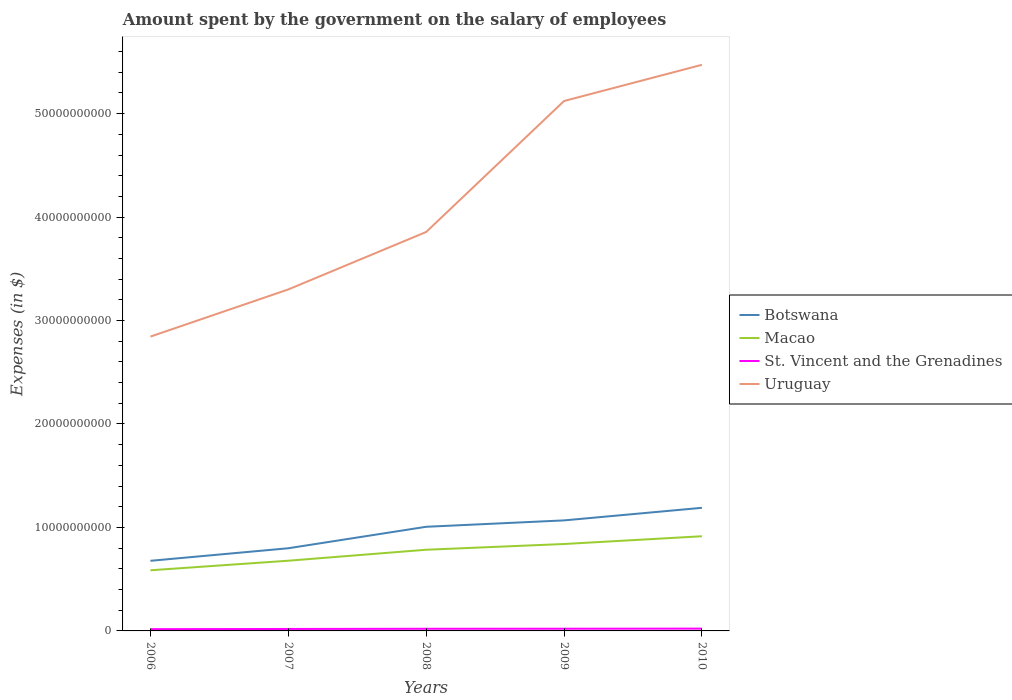How many different coloured lines are there?
Give a very brief answer. 4. Does the line corresponding to Botswana intersect with the line corresponding to Uruguay?
Make the answer very short. No. Across all years, what is the maximum amount spent on the salary of employees by the government in Botswana?
Give a very brief answer. 6.78e+09. What is the total amount spent on the salary of employees by the government in Macao in the graph?
Your answer should be compact. -9.25e+08. What is the difference between the highest and the second highest amount spent on the salary of employees by the government in St. Vincent and the Grenadines?
Your answer should be compact. 5.05e+07. What is the difference between the highest and the lowest amount spent on the salary of employees by the government in Botswana?
Provide a succinct answer. 3. How many lines are there?
Provide a short and direct response. 4. How many years are there in the graph?
Keep it short and to the point. 5. What is the difference between two consecutive major ticks on the Y-axis?
Your response must be concise. 1.00e+1. Are the values on the major ticks of Y-axis written in scientific E-notation?
Offer a terse response. No. Where does the legend appear in the graph?
Your response must be concise. Center right. What is the title of the graph?
Make the answer very short. Amount spent by the government on the salary of employees. What is the label or title of the X-axis?
Offer a very short reply. Years. What is the label or title of the Y-axis?
Ensure brevity in your answer.  Expenses (in $). What is the Expenses (in $) of Botswana in 2006?
Provide a short and direct response. 6.78e+09. What is the Expenses (in $) in Macao in 2006?
Ensure brevity in your answer.  5.86e+09. What is the Expenses (in $) of St. Vincent and the Grenadines in 2006?
Provide a succinct answer. 1.71e+08. What is the Expenses (in $) in Uruguay in 2006?
Make the answer very short. 2.84e+1. What is the Expenses (in $) of Botswana in 2007?
Your answer should be compact. 7.99e+09. What is the Expenses (in $) of Macao in 2007?
Give a very brief answer. 6.79e+09. What is the Expenses (in $) in St. Vincent and the Grenadines in 2007?
Offer a terse response. 1.89e+08. What is the Expenses (in $) in Uruguay in 2007?
Your response must be concise. 3.30e+1. What is the Expenses (in $) in Botswana in 2008?
Ensure brevity in your answer.  1.01e+1. What is the Expenses (in $) of Macao in 2008?
Provide a succinct answer. 7.85e+09. What is the Expenses (in $) of St. Vincent and the Grenadines in 2008?
Make the answer very short. 2.07e+08. What is the Expenses (in $) of Uruguay in 2008?
Give a very brief answer. 3.86e+1. What is the Expenses (in $) of Botswana in 2009?
Give a very brief answer. 1.07e+1. What is the Expenses (in $) of Macao in 2009?
Your response must be concise. 8.40e+09. What is the Expenses (in $) of St. Vincent and the Grenadines in 2009?
Your response must be concise. 2.12e+08. What is the Expenses (in $) of Uruguay in 2009?
Provide a short and direct response. 5.12e+1. What is the Expenses (in $) of Botswana in 2010?
Give a very brief answer. 1.19e+1. What is the Expenses (in $) in Macao in 2010?
Your answer should be very brief. 9.15e+09. What is the Expenses (in $) in St. Vincent and the Grenadines in 2010?
Keep it short and to the point. 2.22e+08. What is the Expenses (in $) of Uruguay in 2010?
Make the answer very short. 5.47e+1. Across all years, what is the maximum Expenses (in $) in Botswana?
Provide a short and direct response. 1.19e+1. Across all years, what is the maximum Expenses (in $) of Macao?
Keep it short and to the point. 9.15e+09. Across all years, what is the maximum Expenses (in $) in St. Vincent and the Grenadines?
Offer a very short reply. 2.22e+08. Across all years, what is the maximum Expenses (in $) of Uruguay?
Offer a terse response. 5.47e+1. Across all years, what is the minimum Expenses (in $) of Botswana?
Keep it short and to the point. 6.78e+09. Across all years, what is the minimum Expenses (in $) in Macao?
Your answer should be very brief. 5.86e+09. Across all years, what is the minimum Expenses (in $) of St. Vincent and the Grenadines?
Ensure brevity in your answer.  1.71e+08. Across all years, what is the minimum Expenses (in $) in Uruguay?
Offer a terse response. 2.84e+1. What is the total Expenses (in $) in Botswana in the graph?
Your response must be concise. 4.74e+1. What is the total Expenses (in $) of Macao in the graph?
Your answer should be compact. 3.80e+1. What is the total Expenses (in $) of St. Vincent and the Grenadines in the graph?
Ensure brevity in your answer.  1.00e+09. What is the total Expenses (in $) in Uruguay in the graph?
Provide a short and direct response. 2.06e+11. What is the difference between the Expenses (in $) in Botswana in 2006 and that in 2007?
Your response must be concise. -1.21e+09. What is the difference between the Expenses (in $) of Macao in 2006 and that in 2007?
Your answer should be very brief. -9.25e+08. What is the difference between the Expenses (in $) of St. Vincent and the Grenadines in 2006 and that in 2007?
Your response must be concise. -1.77e+07. What is the difference between the Expenses (in $) of Uruguay in 2006 and that in 2007?
Your response must be concise. -4.56e+09. What is the difference between the Expenses (in $) of Botswana in 2006 and that in 2008?
Your response must be concise. -3.29e+09. What is the difference between the Expenses (in $) in Macao in 2006 and that in 2008?
Your response must be concise. -1.99e+09. What is the difference between the Expenses (in $) of St. Vincent and the Grenadines in 2006 and that in 2008?
Offer a very short reply. -3.55e+07. What is the difference between the Expenses (in $) in Uruguay in 2006 and that in 2008?
Your answer should be very brief. -1.01e+1. What is the difference between the Expenses (in $) in Botswana in 2006 and that in 2009?
Your response must be concise. -3.91e+09. What is the difference between the Expenses (in $) of Macao in 2006 and that in 2009?
Offer a very short reply. -2.54e+09. What is the difference between the Expenses (in $) in St. Vincent and the Grenadines in 2006 and that in 2009?
Offer a terse response. -4.07e+07. What is the difference between the Expenses (in $) of Uruguay in 2006 and that in 2009?
Make the answer very short. -2.28e+1. What is the difference between the Expenses (in $) in Botswana in 2006 and that in 2010?
Your answer should be compact. -5.12e+09. What is the difference between the Expenses (in $) of Macao in 2006 and that in 2010?
Ensure brevity in your answer.  -3.29e+09. What is the difference between the Expenses (in $) of St. Vincent and the Grenadines in 2006 and that in 2010?
Offer a terse response. -5.05e+07. What is the difference between the Expenses (in $) in Uruguay in 2006 and that in 2010?
Provide a short and direct response. -2.63e+1. What is the difference between the Expenses (in $) of Botswana in 2007 and that in 2008?
Your answer should be very brief. -2.08e+09. What is the difference between the Expenses (in $) in Macao in 2007 and that in 2008?
Offer a very short reply. -1.06e+09. What is the difference between the Expenses (in $) of St. Vincent and the Grenadines in 2007 and that in 2008?
Give a very brief answer. -1.78e+07. What is the difference between the Expenses (in $) in Uruguay in 2007 and that in 2008?
Your response must be concise. -5.55e+09. What is the difference between the Expenses (in $) in Botswana in 2007 and that in 2009?
Your response must be concise. -2.69e+09. What is the difference between the Expenses (in $) in Macao in 2007 and that in 2009?
Keep it short and to the point. -1.62e+09. What is the difference between the Expenses (in $) in St. Vincent and the Grenadines in 2007 and that in 2009?
Your answer should be very brief. -2.30e+07. What is the difference between the Expenses (in $) in Uruguay in 2007 and that in 2009?
Your answer should be very brief. -1.82e+1. What is the difference between the Expenses (in $) of Botswana in 2007 and that in 2010?
Provide a succinct answer. -3.91e+09. What is the difference between the Expenses (in $) of Macao in 2007 and that in 2010?
Keep it short and to the point. -2.36e+09. What is the difference between the Expenses (in $) of St. Vincent and the Grenadines in 2007 and that in 2010?
Provide a succinct answer. -3.28e+07. What is the difference between the Expenses (in $) of Uruguay in 2007 and that in 2010?
Offer a very short reply. -2.17e+1. What is the difference between the Expenses (in $) of Botswana in 2008 and that in 2009?
Provide a succinct answer. -6.17e+08. What is the difference between the Expenses (in $) in Macao in 2008 and that in 2009?
Offer a terse response. -5.54e+08. What is the difference between the Expenses (in $) in St. Vincent and the Grenadines in 2008 and that in 2009?
Offer a terse response. -5.20e+06. What is the difference between the Expenses (in $) of Uruguay in 2008 and that in 2009?
Provide a short and direct response. -1.27e+1. What is the difference between the Expenses (in $) in Botswana in 2008 and that in 2010?
Ensure brevity in your answer.  -1.83e+09. What is the difference between the Expenses (in $) of Macao in 2008 and that in 2010?
Offer a very short reply. -1.30e+09. What is the difference between the Expenses (in $) of St. Vincent and the Grenadines in 2008 and that in 2010?
Offer a very short reply. -1.50e+07. What is the difference between the Expenses (in $) in Uruguay in 2008 and that in 2010?
Ensure brevity in your answer.  -1.62e+1. What is the difference between the Expenses (in $) in Botswana in 2009 and that in 2010?
Provide a succinct answer. -1.22e+09. What is the difference between the Expenses (in $) in Macao in 2009 and that in 2010?
Provide a short and direct response. -7.49e+08. What is the difference between the Expenses (in $) of St. Vincent and the Grenadines in 2009 and that in 2010?
Offer a very short reply. -9.80e+06. What is the difference between the Expenses (in $) in Uruguay in 2009 and that in 2010?
Offer a terse response. -3.50e+09. What is the difference between the Expenses (in $) in Botswana in 2006 and the Expenses (in $) in Macao in 2007?
Your answer should be compact. -8.66e+06. What is the difference between the Expenses (in $) of Botswana in 2006 and the Expenses (in $) of St. Vincent and the Grenadines in 2007?
Ensure brevity in your answer.  6.59e+09. What is the difference between the Expenses (in $) in Botswana in 2006 and the Expenses (in $) in Uruguay in 2007?
Provide a succinct answer. -2.62e+1. What is the difference between the Expenses (in $) in Macao in 2006 and the Expenses (in $) in St. Vincent and the Grenadines in 2007?
Provide a short and direct response. 5.67e+09. What is the difference between the Expenses (in $) of Macao in 2006 and the Expenses (in $) of Uruguay in 2007?
Your answer should be very brief. -2.71e+1. What is the difference between the Expenses (in $) of St. Vincent and the Grenadines in 2006 and the Expenses (in $) of Uruguay in 2007?
Offer a terse response. -3.28e+1. What is the difference between the Expenses (in $) in Botswana in 2006 and the Expenses (in $) in Macao in 2008?
Your response must be concise. -1.07e+09. What is the difference between the Expenses (in $) of Botswana in 2006 and the Expenses (in $) of St. Vincent and the Grenadines in 2008?
Keep it short and to the point. 6.57e+09. What is the difference between the Expenses (in $) of Botswana in 2006 and the Expenses (in $) of Uruguay in 2008?
Ensure brevity in your answer.  -3.18e+1. What is the difference between the Expenses (in $) of Macao in 2006 and the Expenses (in $) of St. Vincent and the Grenadines in 2008?
Your answer should be very brief. 5.65e+09. What is the difference between the Expenses (in $) in Macao in 2006 and the Expenses (in $) in Uruguay in 2008?
Offer a very short reply. -3.27e+1. What is the difference between the Expenses (in $) in St. Vincent and the Grenadines in 2006 and the Expenses (in $) in Uruguay in 2008?
Your response must be concise. -3.84e+1. What is the difference between the Expenses (in $) of Botswana in 2006 and the Expenses (in $) of Macao in 2009?
Your answer should be compact. -1.62e+09. What is the difference between the Expenses (in $) of Botswana in 2006 and the Expenses (in $) of St. Vincent and the Grenadines in 2009?
Provide a succinct answer. 6.57e+09. What is the difference between the Expenses (in $) in Botswana in 2006 and the Expenses (in $) in Uruguay in 2009?
Make the answer very short. -4.44e+1. What is the difference between the Expenses (in $) of Macao in 2006 and the Expenses (in $) of St. Vincent and the Grenadines in 2009?
Make the answer very short. 5.65e+09. What is the difference between the Expenses (in $) of Macao in 2006 and the Expenses (in $) of Uruguay in 2009?
Keep it short and to the point. -4.54e+1. What is the difference between the Expenses (in $) of St. Vincent and the Grenadines in 2006 and the Expenses (in $) of Uruguay in 2009?
Keep it short and to the point. -5.10e+1. What is the difference between the Expenses (in $) of Botswana in 2006 and the Expenses (in $) of Macao in 2010?
Provide a succinct answer. -2.37e+09. What is the difference between the Expenses (in $) in Botswana in 2006 and the Expenses (in $) in St. Vincent and the Grenadines in 2010?
Make the answer very short. 6.56e+09. What is the difference between the Expenses (in $) of Botswana in 2006 and the Expenses (in $) of Uruguay in 2010?
Ensure brevity in your answer.  -4.79e+1. What is the difference between the Expenses (in $) in Macao in 2006 and the Expenses (in $) in St. Vincent and the Grenadines in 2010?
Provide a short and direct response. 5.64e+09. What is the difference between the Expenses (in $) of Macao in 2006 and the Expenses (in $) of Uruguay in 2010?
Offer a terse response. -4.89e+1. What is the difference between the Expenses (in $) of St. Vincent and the Grenadines in 2006 and the Expenses (in $) of Uruguay in 2010?
Your answer should be very brief. -5.45e+1. What is the difference between the Expenses (in $) of Botswana in 2007 and the Expenses (in $) of Macao in 2008?
Your answer should be compact. 1.43e+08. What is the difference between the Expenses (in $) of Botswana in 2007 and the Expenses (in $) of St. Vincent and the Grenadines in 2008?
Keep it short and to the point. 7.78e+09. What is the difference between the Expenses (in $) in Botswana in 2007 and the Expenses (in $) in Uruguay in 2008?
Your answer should be very brief. -3.06e+1. What is the difference between the Expenses (in $) in Macao in 2007 and the Expenses (in $) in St. Vincent and the Grenadines in 2008?
Your response must be concise. 6.58e+09. What is the difference between the Expenses (in $) in Macao in 2007 and the Expenses (in $) in Uruguay in 2008?
Ensure brevity in your answer.  -3.18e+1. What is the difference between the Expenses (in $) of St. Vincent and the Grenadines in 2007 and the Expenses (in $) of Uruguay in 2008?
Offer a very short reply. -3.84e+1. What is the difference between the Expenses (in $) of Botswana in 2007 and the Expenses (in $) of Macao in 2009?
Keep it short and to the point. -4.11e+08. What is the difference between the Expenses (in $) of Botswana in 2007 and the Expenses (in $) of St. Vincent and the Grenadines in 2009?
Make the answer very short. 7.78e+09. What is the difference between the Expenses (in $) in Botswana in 2007 and the Expenses (in $) in Uruguay in 2009?
Your answer should be compact. -4.32e+1. What is the difference between the Expenses (in $) of Macao in 2007 and the Expenses (in $) of St. Vincent and the Grenadines in 2009?
Your answer should be compact. 6.57e+09. What is the difference between the Expenses (in $) in Macao in 2007 and the Expenses (in $) in Uruguay in 2009?
Give a very brief answer. -4.44e+1. What is the difference between the Expenses (in $) of St. Vincent and the Grenadines in 2007 and the Expenses (in $) of Uruguay in 2009?
Make the answer very short. -5.10e+1. What is the difference between the Expenses (in $) of Botswana in 2007 and the Expenses (in $) of Macao in 2010?
Provide a short and direct response. -1.16e+09. What is the difference between the Expenses (in $) in Botswana in 2007 and the Expenses (in $) in St. Vincent and the Grenadines in 2010?
Offer a very short reply. 7.77e+09. What is the difference between the Expenses (in $) in Botswana in 2007 and the Expenses (in $) in Uruguay in 2010?
Ensure brevity in your answer.  -4.67e+1. What is the difference between the Expenses (in $) in Macao in 2007 and the Expenses (in $) in St. Vincent and the Grenadines in 2010?
Keep it short and to the point. 6.56e+09. What is the difference between the Expenses (in $) of Macao in 2007 and the Expenses (in $) of Uruguay in 2010?
Ensure brevity in your answer.  -4.79e+1. What is the difference between the Expenses (in $) of St. Vincent and the Grenadines in 2007 and the Expenses (in $) of Uruguay in 2010?
Provide a succinct answer. -5.45e+1. What is the difference between the Expenses (in $) in Botswana in 2008 and the Expenses (in $) in Macao in 2009?
Offer a terse response. 1.66e+09. What is the difference between the Expenses (in $) of Botswana in 2008 and the Expenses (in $) of St. Vincent and the Grenadines in 2009?
Your response must be concise. 9.85e+09. What is the difference between the Expenses (in $) in Botswana in 2008 and the Expenses (in $) in Uruguay in 2009?
Ensure brevity in your answer.  -4.12e+1. What is the difference between the Expenses (in $) in Macao in 2008 and the Expenses (in $) in St. Vincent and the Grenadines in 2009?
Keep it short and to the point. 7.64e+09. What is the difference between the Expenses (in $) of Macao in 2008 and the Expenses (in $) of Uruguay in 2009?
Provide a short and direct response. -4.34e+1. What is the difference between the Expenses (in $) of St. Vincent and the Grenadines in 2008 and the Expenses (in $) of Uruguay in 2009?
Keep it short and to the point. -5.10e+1. What is the difference between the Expenses (in $) of Botswana in 2008 and the Expenses (in $) of Macao in 2010?
Make the answer very short. 9.16e+08. What is the difference between the Expenses (in $) in Botswana in 2008 and the Expenses (in $) in St. Vincent and the Grenadines in 2010?
Your answer should be very brief. 9.84e+09. What is the difference between the Expenses (in $) of Botswana in 2008 and the Expenses (in $) of Uruguay in 2010?
Give a very brief answer. -4.47e+1. What is the difference between the Expenses (in $) in Macao in 2008 and the Expenses (in $) in St. Vincent and the Grenadines in 2010?
Offer a very short reply. 7.63e+09. What is the difference between the Expenses (in $) of Macao in 2008 and the Expenses (in $) of Uruguay in 2010?
Make the answer very short. -4.69e+1. What is the difference between the Expenses (in $) in St. Vincent and the Grenadines in 2008 and the Expenses (in $) in Uruguay in 2010?
Give a very brief answer. -5.45e+1. What is the difference between the Expenses (in $) in Botswana in 2009 and the Expenses (in $) in Macao in 2010?
Provide a succinct answer. 1.53e+09. What is the difference between the Expenses (in $) of Botswana in 2009 and the Expenses (in $) of St. Vincent and the Grenadines in 2010?
Make the answer very short. 1.05e+1. What is the difference between the Expenses (in $) in Botswana in 2009 and the Expenses (in $) in Uruguay in 2010?
Keep it short and to the point. -4.40e+1. What is the difference between the Expenses (in $) of Macao in 2009 and the Expenses (in $) of St. Vincent and the Grenadines in 2010?
Provide a succinct answer. 8.18e+09. What is the difference between the Expenses (in $) of Macao in 2009 and the Expenses (in $) of Uruguay in 2010?
Your response must be concise. -4.63e+1. What is the difference between the Expenses (in $) of St. Vincent and the Grenadines in 2009 and the Expenses (in $) of Uruguay in 2010?
Your answer should be compact. -5.45e+1. What is the average Expenses (in $) in Botswana per year?
Provide a succinct answer. 9.48e+09. What is the average Expenses (in $) of Macao per year?
Keep it short and to the point. 7.61e+09. What is the average Expenses (in $) of St. Vincent and the Grenadines per year?
Ensure brevity in your answer.  2.00e+08. What is the average Expenses (in $) in Uruguay per year?
Your answer should be compact. 4.12e+1. In the year 2006, what is the difference between the Expenses (in $) of Botswana and Expenses (in $) of Macao?
Provide a succinct answer. 9.16e+08. In the year 2006, what is the difference between the Expenses (in $) in Botswana and Expenses (in $) in St. Vincent and the Grenadines?
Keep it short and to the point. 6.61e+09. In the year 2006, what is the difference between the Expenses (in $) of Botswana and Expenses (in $) of Uruguay?
Your response must be concise. -2.17e+1. In the year 2006, what is the difference between the Expenses (in $) in Macao and Expenses (in $) in St. Vincent and the Grenadines?
Your response must be concise. 5.69e+09. In the year 2006, what is the difference between the Expenses (in $) in Macao and Expenses (in $) in Uruguay?
Your answer should be very brief. -2.26e+1. In the year 2006, what is the difference between the Expenses (in $) of St. Vincent and the Grenadines and Expenses (in $) of Uruguay?
Your answer should be compact. -2.83e+1. In the year 2007, what is the difference between the Expenses (in $) in Botswana and Expenses (in $) in Macao?
Make the answer very short. 1.20e+09. In the year 2007, what is the difference between the Expenses (in $) in Botswana and Expenses (in $) in St. Vincent and the Grenadines?
Your response must be concise. 7.80e+09. In the year 2007, what is the difference between the Expenses (in $) in Botswana and Expenses (in $) in Uruguay?
Give a very brief answer. -2.50e+1. In the year 2007, what is the difference between the Expenses (in $) in Macao and Expenses (in $) in St. Vincent and the Grenadines?
Make the answer very short. 6.60e+09. In the year 2007, what is the difference between the Expenses (in $) of Macao and Expenses (in $) of Uruguay?
Your response must be concise. -2.62e+1. In the year 2007, what is the difference between the Expenses (in $) in St. Vincent and the Grenadines and Expenses (in $) in Uruguay?
Offer a very short reply. -3.28e+1. In the year 2008, what is the difference between the Expenses (in $) in Botswana and Expenses (in $) in Macao?
Your response must be concise. 2.22e+09. In the year 2008, what is the difference between the Expenses (in $) of Botswana and Expenses (in $) of St. Vincent and the Grenadines?
Provide a succinct answer. 9.86e+09. In the year 2008, what is the difference between the Expenses (in $) of Botswana and Expenses (in $) of Uruguay?
Give a very brief answer. -2.85e+1. In the year 2008, what is the difference between the Expenses (in $) of Macao and Expenses (in $) of St. Vincent and the Grenadines?
Your answer should be compact. 7.64e+09. In the year 2008, what is the difference between the Expenses (in $) in Macao and Expenses (in $) in Uruguay?
Provide a succinct answer. -3.07e+1. In the year 2008, what is the difference between the Expenses (in $) in St. Vincent and the Grenadines and Expenses (in $) in Uruguay?
Provide a succinct answer. -3.84e+1. In the year 2009, what is the difference between the Expenses (in $) in Botswana and Expenses (in $) in Macao?
Ensure brevity in your answer.  2.28e+09. In the year 2009, what is the difference between the Expenses (in $) in Botswana and Expenses (in $) in St. Vincent and the Grenadines?
Your answer should be compact. 1.05e+1. In the year 2009, what is the difference between the Expenses (in $) of Botswana and Expenses (in $) of Uruguay?
Give a very brief answer. -4.05e+1. In the year 2009, what is the difference between the Expenses (in $) in Macao and Expenses (in $) in St. Vincent and the Grenadines?
Ensure brevity in your answer.  8.19e+09. In the year 2009, what is the difference between the Expenses (in $) of Macao and Expenses (in $) of Uruguay?
Your answer should be compact. -4.28e+1. In the year 2009, what is the difference between the Expenses (in $) of St. Vincent and the Grenadines and Expenses (in $) of Uruguay?
Your answer should be very brief. -5.10e+1. In the year 2010, what is the difference between the Expenses (in $) in Botswana and Expenses (in $) in Macao?
Give a very brief answer. 2.75e+09. In the year 2010, what is the difference between the Expenses (in $) of Botswana and Expenses (in $) of St. Vincent and the Grenadines?
Your answer should be very brief. 1.17e+1. In the year 2010, what is the difference between the Expenses (in $) of Botswana and Expenses (in $) of Uruguay?
Give a very brief answer. -4.28e+1. In the year 2010, what is the difference between the Expenses (in $) in Macao and Expenses (in $) in St. Vincent and the Grenadines?
Your answer should be very brief. 8.93e+09. In the year 2010, what is the difference between the Expenses (in $) in Macao and Expenses (in $) in Uruguay?
Offer a terse response. -4.56e+1. In the year 2010, what is the difference between the Expenses (in $) of St. Vincent and the Grenadines and Expenses (in $) of Uruguay?
Your answer should be compact. -5.45e+1. What is the ratio of the Expenses (in $) of Botswana in 2006 to that in 2007?
Offer a very short reply. 0.85. What is the ratio of the Expenses (in $) of Macao in 2006 to that in 2007?
Offer a terse response. 0.86. What is the ratio of the Expenses (in $) in St. Vincent and the Grenadines in 2006 to that in 2007?
Ensure brevity in your answer.  0.91. What is the ratio of the Expenses (in $) in Uruguay in 2006 to that in 2007?
Provide a short and direct response. 0.86. What is the ratio of the Expenses (in $) of Botswana in 2006 to that in 2008?
Ensure brevity in your answer.  0.67. What is the ratio of the Expenses (in $) of Macao in 2006 to that in 2008?
Provide a succinct answer. 0.75. What is the ratio of the Expenses (in $) in St. Vincent and the Grenadines in 2006 to that in 2008?
Make the answer very short. 0.83. What is the ratio of the Expenses (in $) in Uruguay in 2006 to that in 2008?
Your answer should be very brief. 0.74. What is the ratio of the Expenses (in $) in Botswana in 2006 to that in 2009?
Ensure brevity in your answer.  0.63. What is the ratio of the Expenses (in $) of Macao in 2006 to that in 2009?
Offer a very short reply. 0.7. What is the ratio of the Expenses (in $) in St. Vincent and the Grenadines in 2006 to that in 2009?
Offer a terse response. 0.81. What is the ratio of the Expenses (in $) in Uruguay in 2006 to that in 2009?
Your response must be concise. 0.56. What is the ratio of the Expenses (in $) of Botswana in 2006 to that in 2010?
Make the answer very short. 0.57. What is the ratio of the Expenses (in $) in Macao in 2006 to that in 2010?
Your response must be concise. 0.64. What is the ratio of the Expenses (in $) of St. Vincent and the Grenadines in 2006 to that in 2010?
Offer a terse response. 0.77. What is the ratio of the Expenses (in $) of Uruguay in 2006 to that in 2010?
Keep it short and to the point. 0.52. What is the ratio of the Expenses (in $) in Botswana in 2007 to that in 2008?
Ensure brevity in your answer.  0.79. What is the ratio of the Expenses (in $) in Macao in 2007 to that in 2008?
Provide a short and direct response. 0.86. What is the ratio of the Expenses (in $) of St. Vincent and the Grenadines in 2007 to that in 2008?
Offer a terse response. 0.91. What is the ratio of the Expenses (in $) of Uruguay in 2007 to that in 2008?
Provide a short and direct response. 0.86. What is the ratio of the Expenses (in $) of Botswana in 2007 to that in 2009?
Keep it short and to the point. 0.75. What is the ratio of the Expenses (in $) of Macao in 2007 to that in 2009?
Ensure brevity in your answer.  0.81. What is the ratio of the Expenses (in $) of St. Vincent and the Grenadines in 2007 to that in 2009?
Your answer should be very brief. 0.89. What is the ratio of the Expenses (in $) of Uruguay in 2007 to that in 2009?
Your answer should be compact. 0.64. What is the ratio of the Expenses (in $) of Botswana in 2007 to that in 2010?
Give a very brief answer. 0.67. What is the ratio of the Expenses (in $) in Macao in 2007 to that in 2010?
Your response must be concise. 0.74. What is the ratio of the Expenses (in $) of St. Vincent and the Grenadines in 2007 to that in 2010?
Keep it short and to the point. 0.85. What is the ratio of the Expenses (in $) in Uruguay in 2007 to that in 2010?
Your answer should be compact. 0.6. What is the ratio of the Expenses (in $) of Botswana in 2008 to that in 2009?
Offer a terse response. 0.94. What is the ratio of the Expenses (in $) of Macao in 2008 to that in 2009?
Offer a very short reply. 0.93. What is the ratio of the Expenses (in $) in St. Vincent and the Grenadines in 2008 to that in 2009?
Offer a very short reply. 0.98. What is the ratio of the Expenses (in $) in Uruguay in 2008 to that in 2009?
Provide a short and direct response. 0.75. What is the ratio of the Expenses (in $) in Botswana in 2008 to that in 2010?
Offer a very short reply. 0.85. What is the ratio of the Expenses (in $) of Macao in 2008 to that in 2010?
Make the answer very short. 0.86. What is the ratio of the Expenses (in $) in St. Vincent and the Grenadines in 2008 to that in 2010?
Your response must be concise. 0.93. What is the ratio of the Expenses (in $) of Uruguay in 2008 to that in 2010?
Offer a very short reply. 0.7. What is the ratio of the Expenses (in $) of Botswana in 2009 to that in 2010?
Give a very brief answer. 0.9. What is the ratio of the Expenses (in $) of Macao in 2009 to that in 2010?
Make the answer very short. 0.92. What is the ratio of the Expenses (in $) in St. Vincent and the Grenadines in 2009 to that in 2010?
Give a very brief answer. 0.96. What is the ratio of the Expenses (in $) in Uruguay in 2009 to that in 2010?
Your answer should be compact. 0.94. What is the difference between the highest and the second highest Expenses (in $) of Botswana?
Your answer should be very brief. 1.22e+09. What is the difference between the highest and the second highest Expenses (in $) in Macao?
Your answer should be very brief. 7.49e+08. What is the difference between the highest and the second highest Expenses (in $) of St. Vincent and the Grenadines?
Provide a short and direct response. 9.80e+06. What is the difference between the highest and the second highest Expenses (in $) in Uruguay?
Ensure brevity in your answer.  3.50e+09. What is the difference between the highest and the lowest Expenses (in $) of Botswana?
Your answer should be compact. 5.12e+09. What is the difference between the highest and the lowest Expenses (in $) in Macao?
Ensure brevity in your answer.  3.29e+09. What is the difference between the highest and the lowest Expenses (in $) of St. Vincent and the Grenadines?
Offer a terse response. 5.05e+07. What is the difference between the highest and the lowest Expenses (in $) of Uruguay?
Make the answer very short. 2.63e+1. 